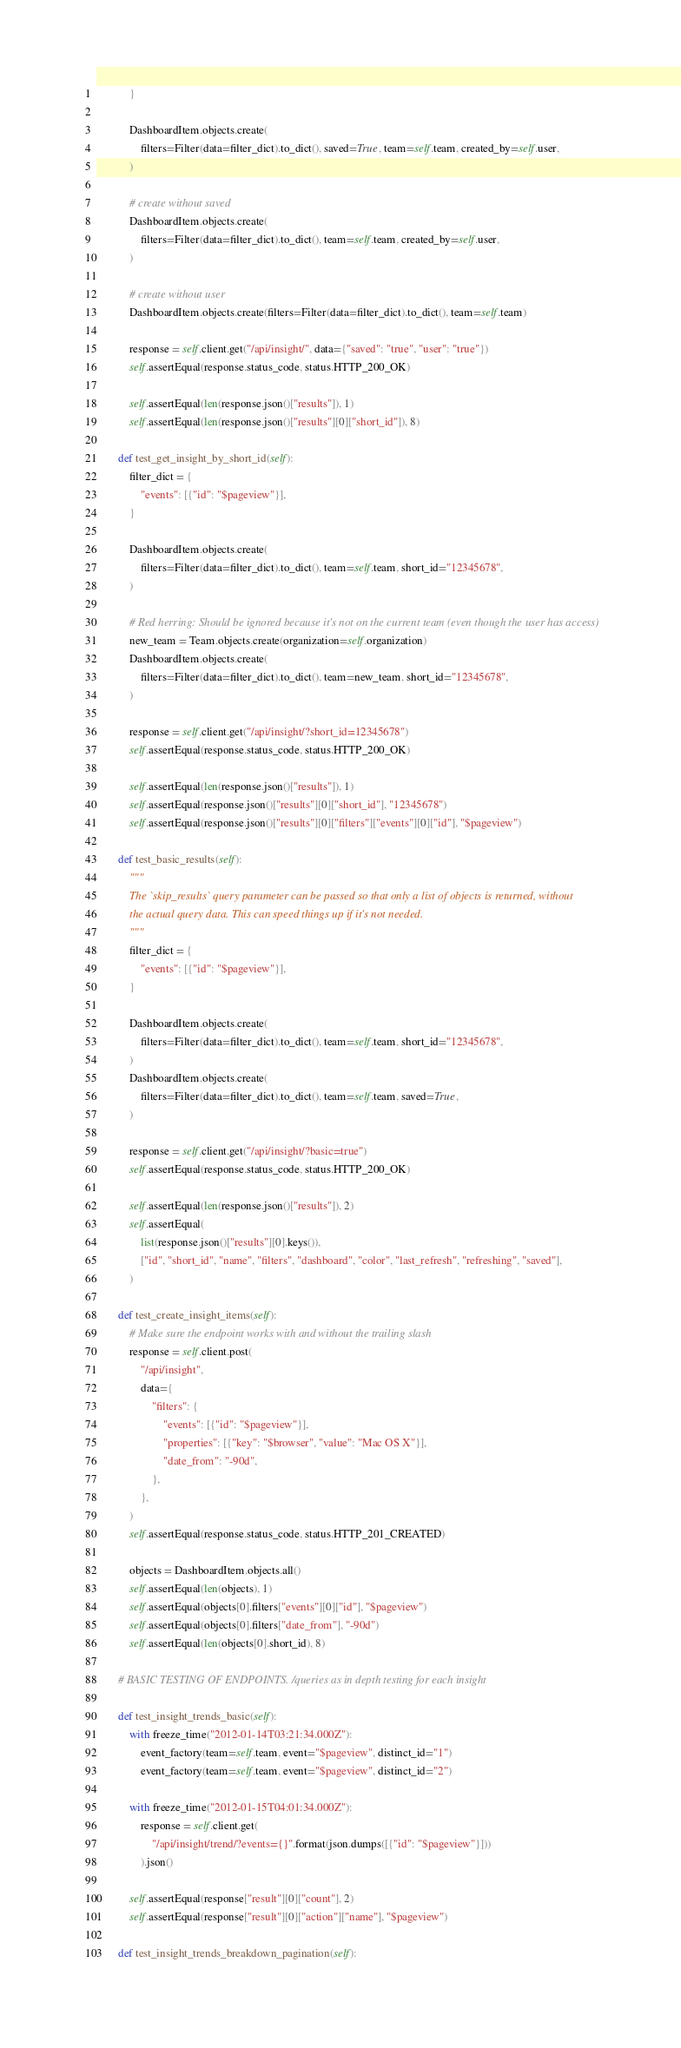<code> <loc_0><loc_0><loc_500><loc_500><_Python_>            }

            DashboardItem.objects.create(
                filters=Filter(data=filter_dict).to_dict(), saved=True, team=self.team, created_by=self.user,
            )

            # create without saved
            DashboardItem.objects.create(
                filters=Filter(data=filter_dict).to_dict(), team=self.team, created_by=self.user,
            )

            # create without user
            DashboardItem.objects.create(filters=Filter(data=filter_dict).to_dict(), team=self.team)

            response = self.client.get("/api/insight/", data={"saved": "true", "user": "true"})
            self.assertEqual(response.status_code, status.HTTP_200_OK)

            self.assertEqual(len(response.json()["results"]), 1)
            self.assertEqual(len(response.json()["results"][0]["short_id"]), 8)

        def test_get_insight_by_short_id(self):
            filter_dict = {
                "events": [{"id": "$pageview"}],
            }

            DashboardItem.objects.create(
                filters=Filter(data=filter_dict).to_dict(), team=self.team, short_id="12345678",
            )

            # Red herring: Should be ignored because it's not on the current team (even though the user has access)
            new_team = Team.objects.create(organization=self.organization)
            DashboardItem.objects.create(
                filters=Filter(data=filter_dict).to_dict(), team=new_team, short_id="12345678",
            )

            response = self.client.get("/api/insight/?short_id=12345678")
            self.assertEqual(response.status_code, status.HTTP_200_OK)

            self.assertEqual(len(response.json()["results"]), 1)
            self.assertEqual(response.json()["results"][0]["short_id"], "12345678")
            self.assertEqual(response.json()["results"][0]["filters"]["events"][0]["id"], "$pageview")

        def test_basic_results(self):
            """
            The `skip_results` query parameter can be passed so that only a list of objects is returned, without
            the actual query data. This can speed things up if it's not needed.
            """
            filter_dict = {
                "events": [{"id": "$pageview"}],
            }

            DashboardItem.objects.create(
                filters=Filter(data=filter_dict).to_dict(), team=self.team, short_id="12345678",
            )
            DashboardItem.objects.create(
                filters=Filter(data=filter_dict).to_dict(), team=self.team, saved=True,
            )

            response = self.client.get("/api/insight/?basic=true")
            self.assertEqual(response.status_code, status.HTTP_200_OK)

            self.assertEqual(len(response.json()["results"]), 2)
            self.assertEqual(
                list(response.json()["results"][0].keys()),
                ["id", "short_id", "name", "filters", "dashboard", "color", "last_refresh", "refreshing", "saved"],
            )

        def test_create_insight_items(self):
            # Make sure the endpoint works with and without the trailing slash
            response = self.client.post(
                "/api/insight",
                data={
                    "filters": {
                        "events": [{"id": "$pageview"}],
                        "properties": [{"key": "$browser", "value": "Mac OS X"}],
                        "date_from": "-90d",
                    },
                },
            )
            self.assertEqual(response.status_code, status.HTTP_201_CREATED)

            objects = DashboardItem.objects.all()
            self.assertEqual(len(objects), 1)
            self.assertEqual(objects[0].filters["events"][0]["id"], "$pageview")
            self.assertEqual(objects[0].filters["date_from"], "-90d")
            self.assertEqual(len(objects[0].short_id), 8)

        # BASIC TESTING OF ENDPOINTS. /queries as in depth testing for each insight

        def test_insight_trends_basic(self):
            with freeze_time("2012-01-14T03:21:34.000Z"):
                event_factory(team=self.team, event="$pageview", distinct_id="1")
                event_factory(team=self.team, event="$pageview", distinct_id="2")

            with freeze_time("2012-01-15T04:01:34.000Z"):
                response = self.client.get(
                    "/api/insight/trend/?events={}".format(json.dumps([{"id": "$pageview"}]))
                ).json()

            self.assertEqual(response["result"][0]["count"], 2)
            self.assertEqual(response["result"][0]["action"]["name"], "$pageview")

        def test_insight_trends_breakdown_pagination(self):</code> 